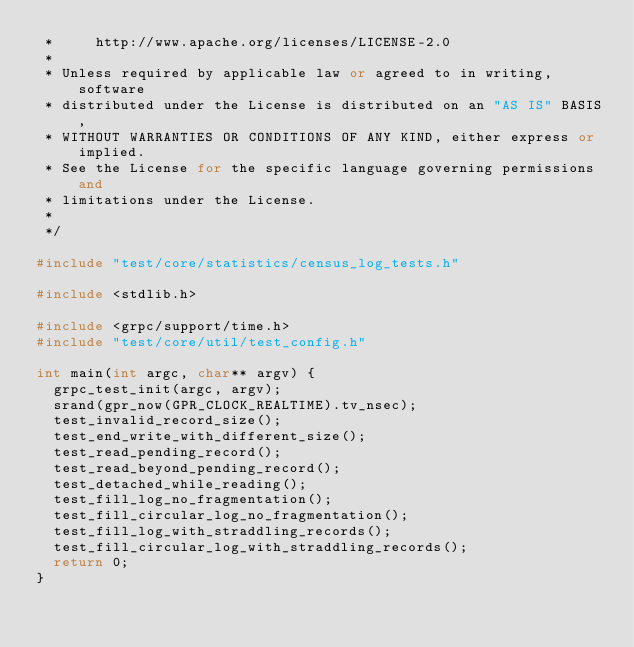Convert code to text. <code><loc_0><loc_0><loc_500><loc_500><_C++_> *     http://www.apache.org/licenses/LICENSE-2.0
 *
 * Unless required by applicable law or agreed to in writing, software
 * distributed under the License is distributed on an "AS IS" BASIS,
 * WITHOUT WARRANTIES OR CONDITIONS OF ANY KIND, either express or implied.
 * See the License for the specific language governing permissions and
 * limitations under the License.
 *
 */

#include "test/core/statistics/census_log_tests.h"

#include <stdlib.h>

#include <grpc/support/time.h>
#include "test/core/util/test_config.h"

int main(int argc, char** argv) {
  grpc_test_init(argc, argv);
  srand(gpr_now(GPR_CLOCK_REALTIME).tv_nsec);
  test_invalid_record_size();
  test_end_write_with_different_size();
  test_read_pending_record();
  test_read_beyond_pending_record();
  test_detached_while_reading();
  test_fill_log_no_fragmentation();
  test_fill_circular_log_no_fragmentation();
  test_fill_log_with_straddling_records();
  test_fill_circular_log_with_straddling_records();
  return 0;
}
</code> 